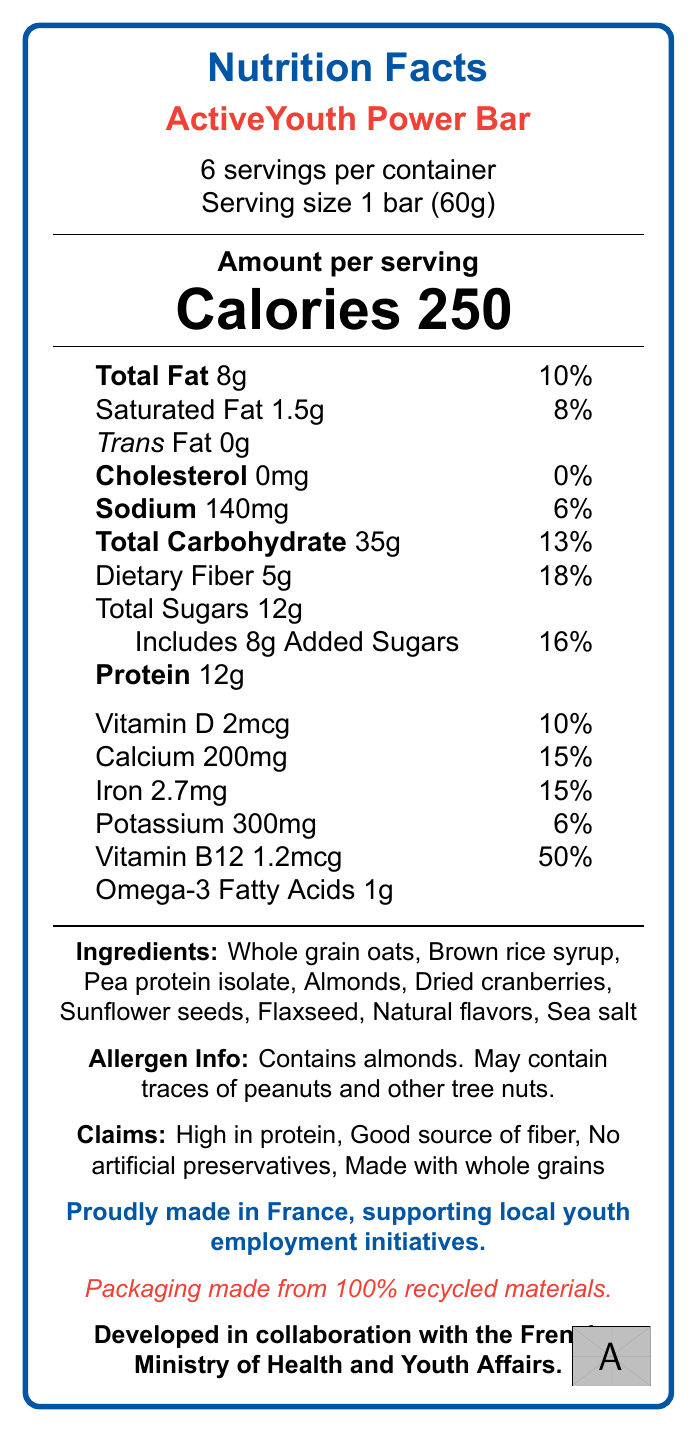what is the serving size for ActiveYouth Power Bar? According to the document, each serving size is 1 bar weighing 60 grams.
Answer: 1 bar (60g) how many servings are there in a container? The document specifies that there are 6 servings per container.
Answer: 6 servings how many grams of protein are in one serving? The Nutrition Facts label lists 12g of protein per serving.
Answer: 12g what is the total amount of sugar per serving? The total sugar content per serving is listed as 12g in the Nutrition Facts.
Answer: 12g how much dietary fiber does one serving provide? The document indicates that one serving contains 5 grams of dietary fiber.
Answer: 5g how much calcium is in a serving of ActiveYouth Power Bar? According to the document, there are 200mg of calcium per serving.
Answer: 200mg what is the percentage of daily value for Vitamin D in one serving? The Nutrition Facts label states that one serving provides 10% of the daily value for Vitamin D.
Answer: 10% which ingredient in the ActiveYouth Power Bar might cause allergies? The allergen information mentions that the bar contains almonds and may also contain traces of peanuts and other tree nuts.
Answer: Almonds who collaborated on the development of this product? A. French Ministry of Health B. French Ministry of Education C. Local Farmers D. French Ministry of Health and Youth Affairs The document states that the product was developed in collaboration with the French Ministry of Health and Youth Affairs.
Answer: D how much total fat is in one serving of ActiveYouth Power Bar? A. 10g B. 8g C. 12g D. 6g The Nutrition Facts label shows that one serving contains 8g of total fat.
Answer: B does the product contain any artificial preservatives? Yes/No One of the claims on the Nutrition Facts label is that the product contains no artificial preservatives.
Answer: No what are the main health claims made about the ActiveYouth Power Bar? The document highlights these four claims about health benefits and product features.
Answer: High in protein, Good source of fiber, No artificial preservatives, Made with whole grains describe the main idea of the document. The document is essentially a detailed overview of the nutritional aspects, ingredient list, health claims, and social responsibility claims of the ActiveYouth Power Bar.
Answer: The document provides the nutritional information for the ActiveYouth Power Bar, including serving size, calories, ingredients, allergen info, and various nutrients. It also emphasizes the product's health benefits, its contribution to local youth employment initiatives in France, its sustainable packaging, and its development in collaboration with the French Ministry of Health and Youth Affairs. how much sodium is there per serving? The document states that each serving contains 140mg of sodium.
Answer: 140mg is there any information about the price of the ActiveYouth Power Bar in the document? The document does not contain any details about the pricing of the ActiveYouth Power Bar.
Answer: Not enough information 